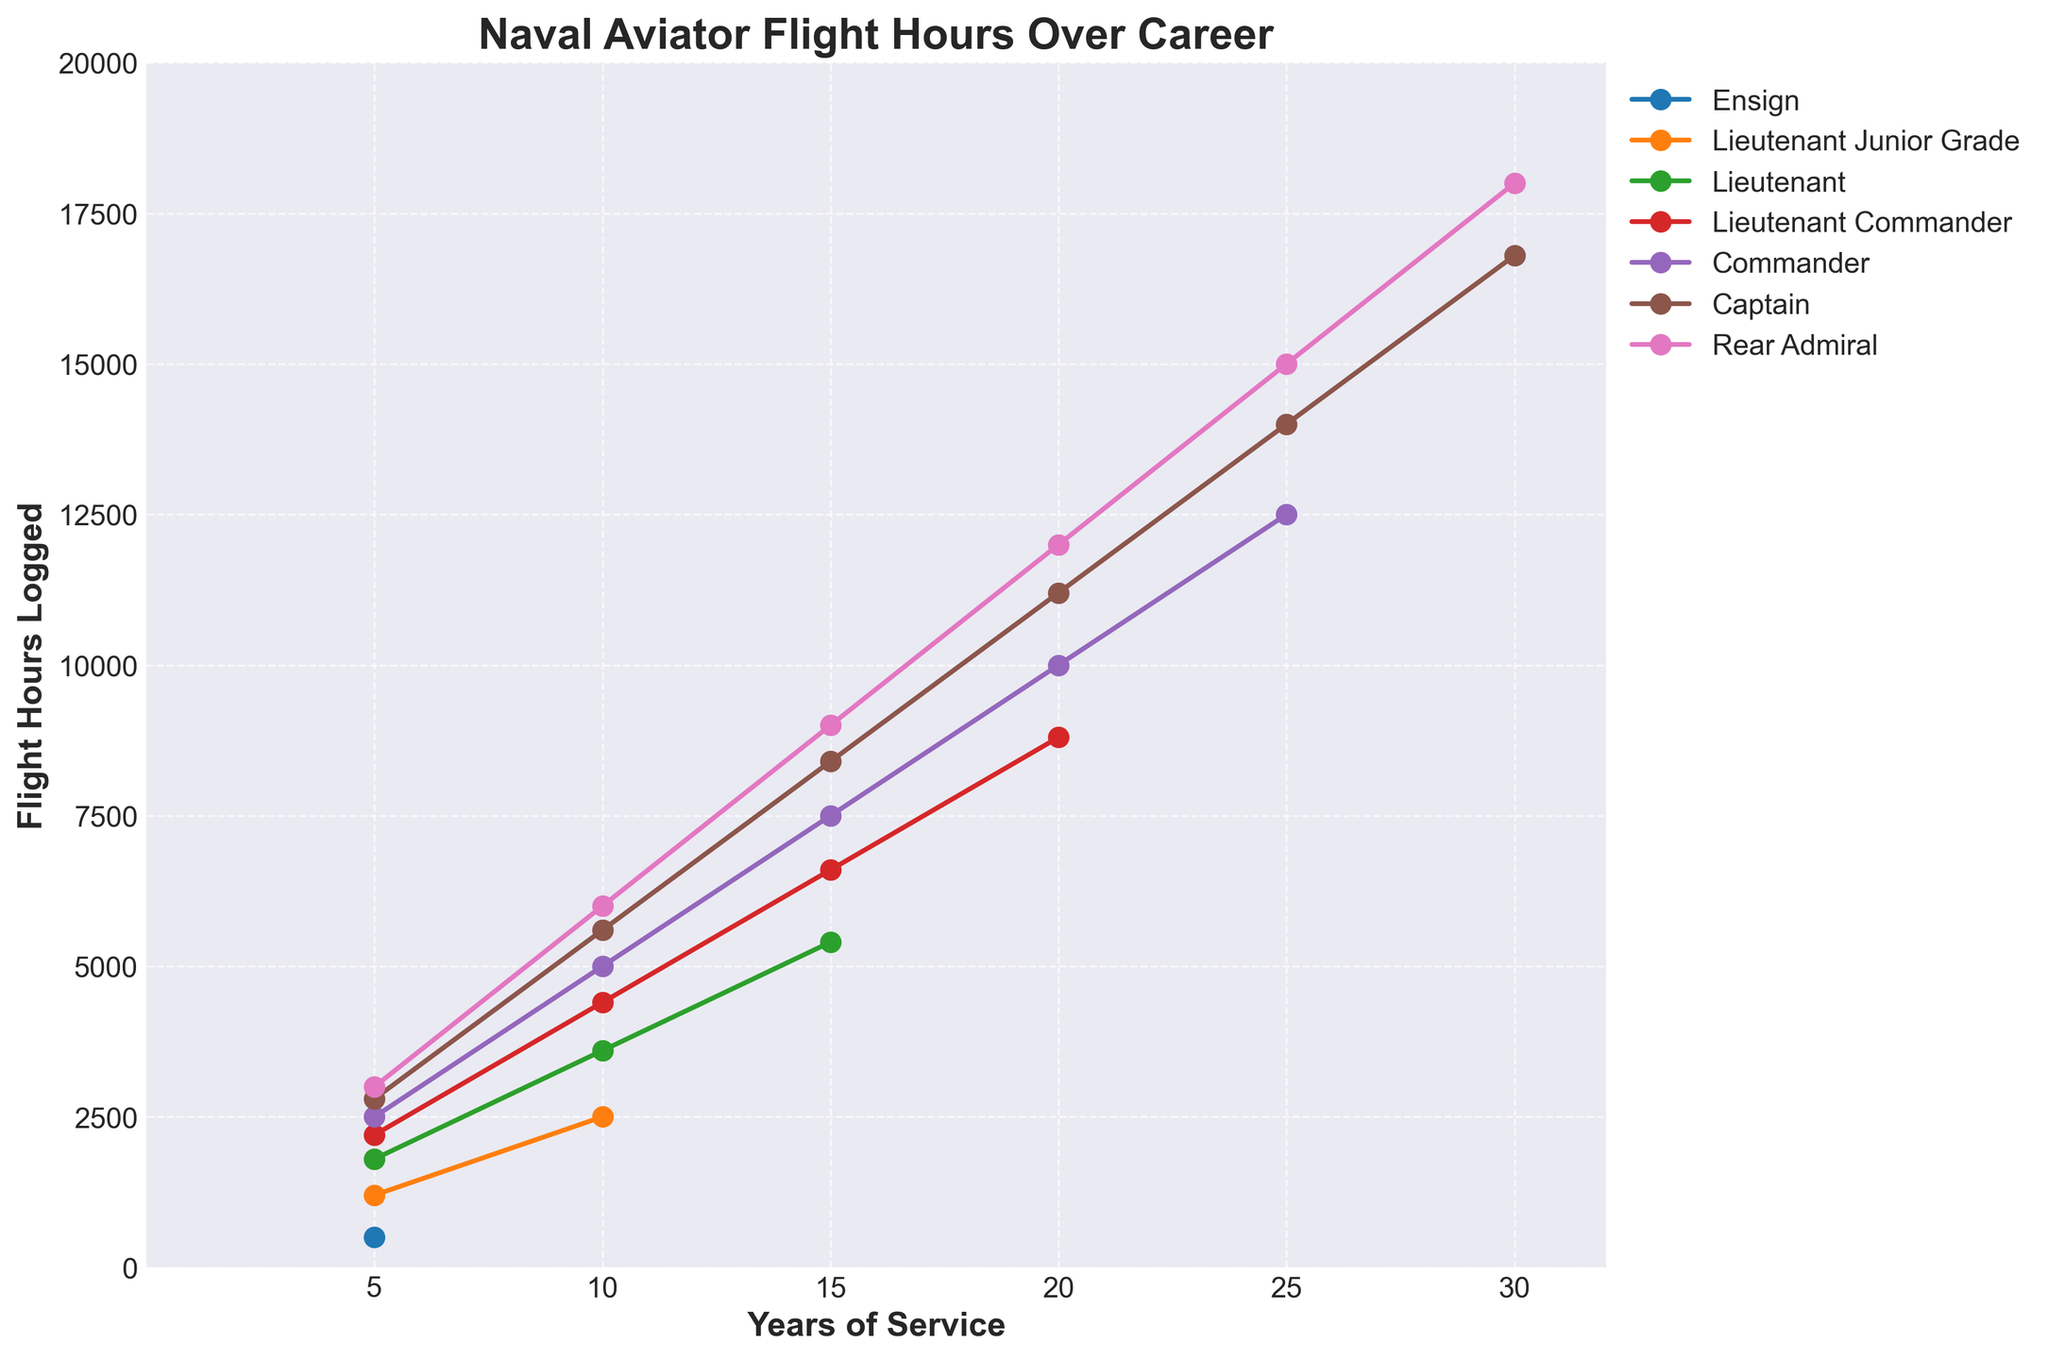1. Which rank has the highest number of flight hours logged after 30 years? Looking at the data points corresponding to each rank after 30 years, the Rear Admiral has the highest flight hours logged, reaching 18,000 hours.
Answer: Rear Admiral 2. How many more flight hours does a Lieutenant Commander log after 10 years compared to a Lieutenant? According to the chart, a Lieutenant Commander logs 4,400 hours after 10 years, while a Lieutenant logs 3,600 hours. The difference is 4,400 - 3,600 = 800 hours.
Answer: 800 3. Between which ranks does the steepest increase in flight hours occur between 20 and 25 years of service? Comparing the slopes of the lines between 20 and 25 years, the steepest increase is between Commander and Captain, where the flight hours increase by 5,000 from 10,000 to 15,000 hours.
Answer: Captain 4. At what years of service do Lieutenant Junior Grades stop accumulating flight hours in the chart? The data points for Lieutenant Junior Grade only exist up to 10 years of service. After 10 years, there are no more entries for this rank in the provided data.
Answer: 10 years 5. What is the average number of flight hours logged by a Commander over the listed years? Summing the flight hours logged by a Commander (2,500, 5,000, 7,500, 10,000, 12,500) and dividing by the number of years listed (5), we get (2,500 + 5,000 + 7,500 + 10,000 + 12,500) / 5 = 7,500 hours.
Answer: 7,500 6. How does the number of flight hours logged by an Ensign compare to that of a Lieutenant Junior Grade after 5 years? An Ensign logs 500 flight hours after 5 years, while a Lieutenant Junior Grade logs 1,200 hours after the same period. 1,200 is greater than 500 by 700 hours.
Answer: 700 hours more 7. How many years does it take for a Captain to log at least 10,000 flight hours? Referring to the graph, a Captain reaches 10,000 flight hours between 20 and 25 years. So, it takes 25 years for a Captain to log at least 10,000 hours.
Answer: 25 years 8. What is the flight hour difference between a Captain and Rear Admiral at 15 years of service? The figure shows that at 15 years of service, a Captain logs 8,400 hours and a Rear Admiral logs 9,000 hours. The difference is 9,000 - 8,400 = 600 hours.
Answer: 600 9. What rank logs 3,600 hours after 10 years of service? In the figure, a Lieutenant logs 3,600 hours after 10 years of service.
Answer: Lieutenant 10. By how many flight hours does a Rear Admiral's total after 30 years surpass a Captain's? According to the chart, after 30 years, a Rear Admiral logs 18,000 hours and a Captain logs 16,800 hours. The difference is 18,000 - 16,800 = 1,200 hours.
Answer: 1,200 